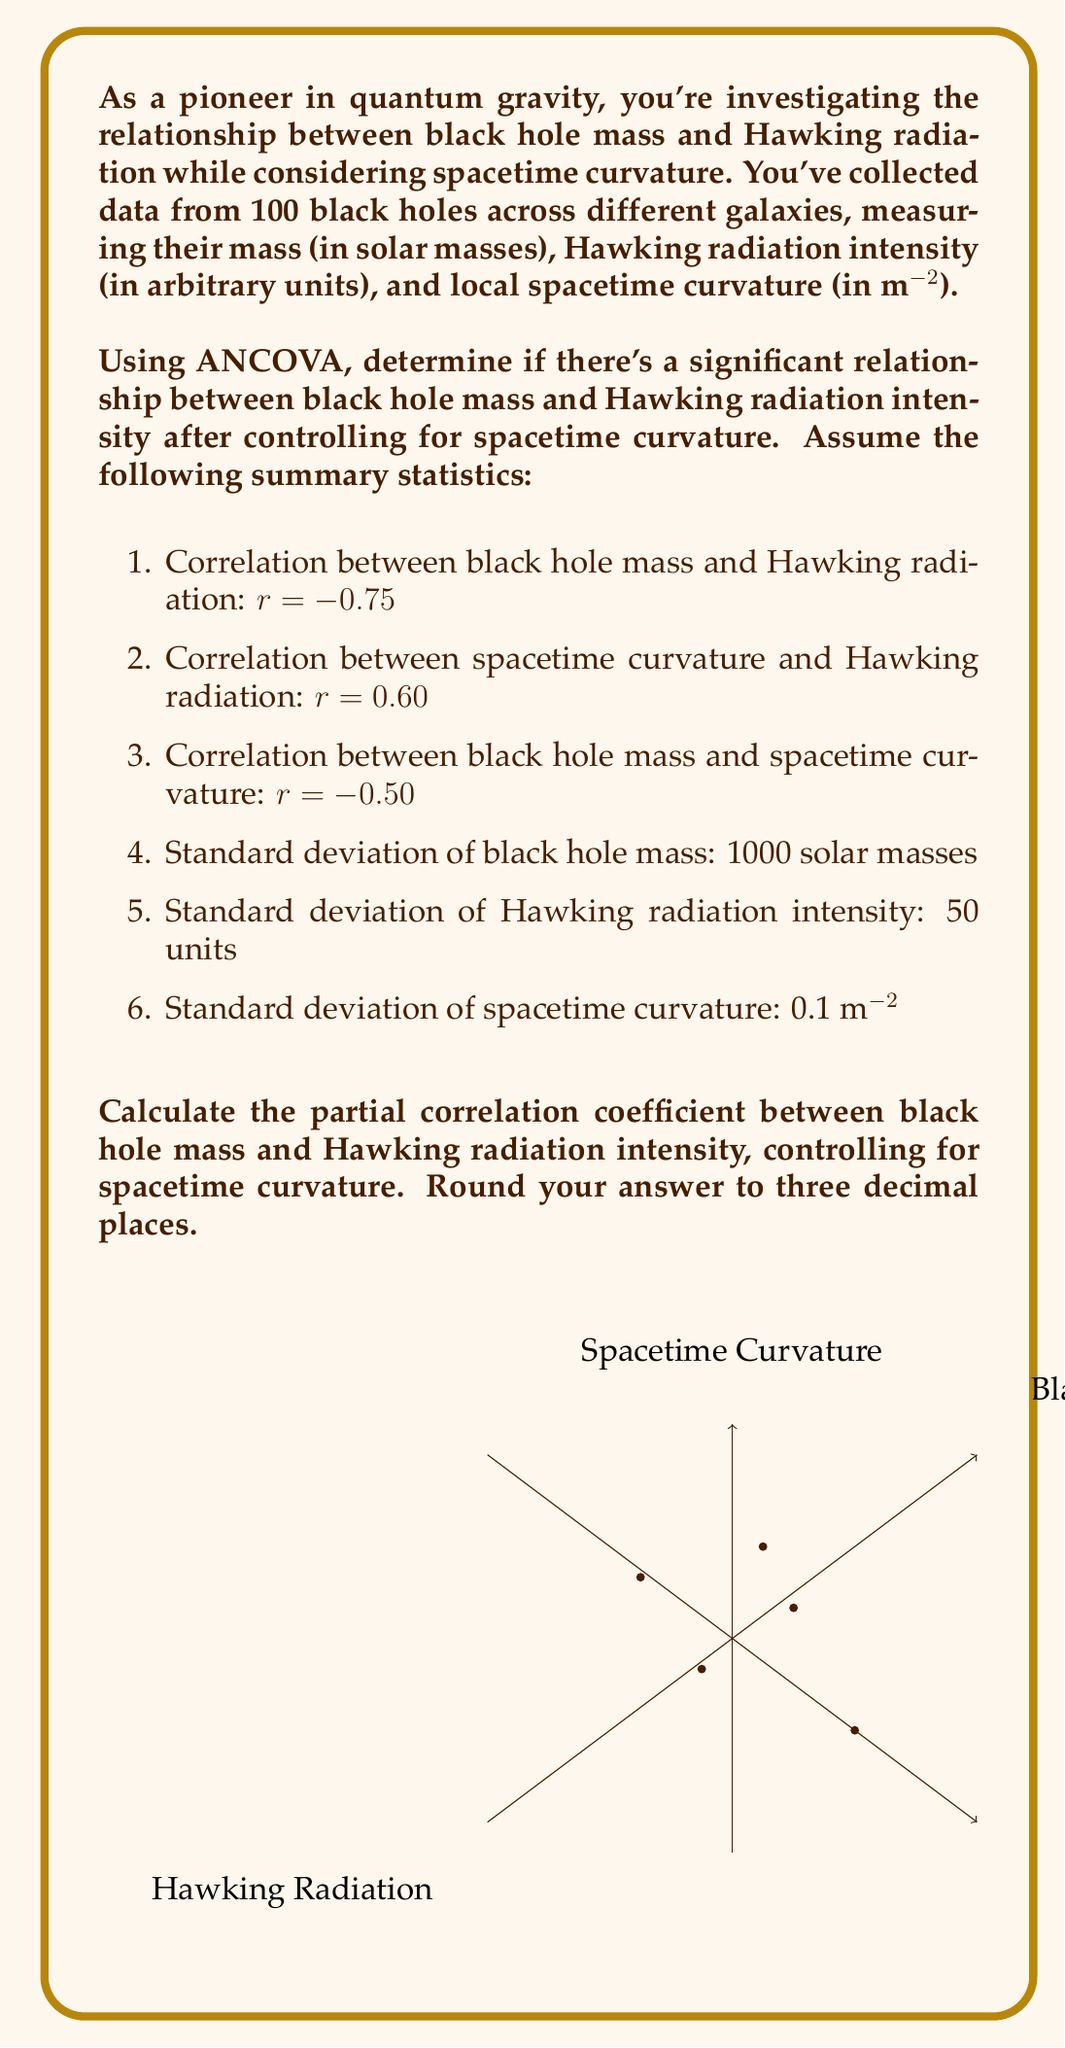Solve this math problem. To solve this problem, we'll use the formula for partial correlation, controlling for a third variable:

$$ r_{12.3} = \frac{r_{12} - r_{13}r_{23}}{\sqrt{(1-r_{13}^2)(1-r_{23}^2)}} $$

Where:
1 = Black hole mass
2 = Hawking radiation intensity
3 = Spacetime curvature

Step 1: Identify the correlation coefficients
$r_{12} = -0.75$ (Black hole mass and Hawking radiation)
$r_{23} = 0.60$ (Spacetime curvature and Hawking radiation)
$r_{13} = -0.50$ (Black hole mass and spacetime curvature)

Step 2: Substitute the values into the formula

$$ r_{12.3} = \frac{-0.75 - (-0.50)(0.60)}{\sqrt{(1-(-0.50)^2)(1-0.60^2)}} $$

Step 3: Simplify the numerator
$$ r_{12.3} = \frac{-0.75 - (-0.30)}{\sqrt{(1-(-0.50)^2)(1-0.60^2)}} = \frac{-0.45}{\sqrt{(1-(-0.50)^2)(1-0.60^2)}} $$

Step 4: Simplify the denominator
$$ r_{12.3} = \frac{-0.45}{\sqrt{(1-0.25)(1-0.36)}} = \frac{-0.45}{\sqrt{(0.75)(0.64)}} = \frac{-0.45}{\sqrt{0.48}} $$

Step 5: Calculate the final result
$$ r_{12.3} = \frac{-0.45}{0.6928} = -0.6495 $$

Step 6: Round to three decimal places
$$ r_{12.3} = -0.650 $$
Answer: $-0.650$ 